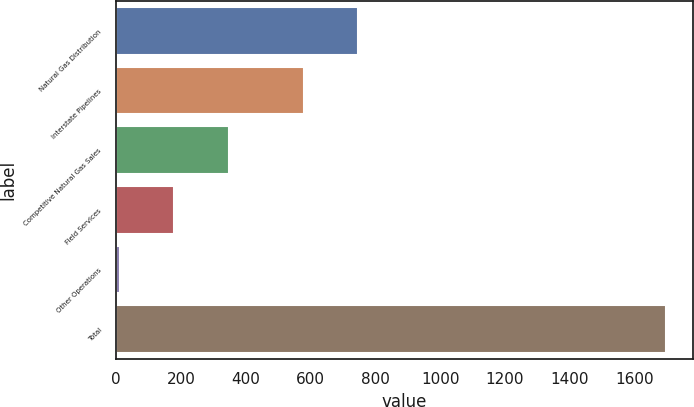<chart> <loc_0><loc_0><loc_500><loc_500><bar_chart><fcel>Natural Gas Distribution<fcel>Interstate Pipelines<fcel>Competitive Natural Gas Sales<fcel>Field Services<fcel>Other Operations<fcel>Total<nl><fcel>747.5<fcel>579<fcel>348<fcel>179.5<fcel>11<fcel>1696<nl></chart> 